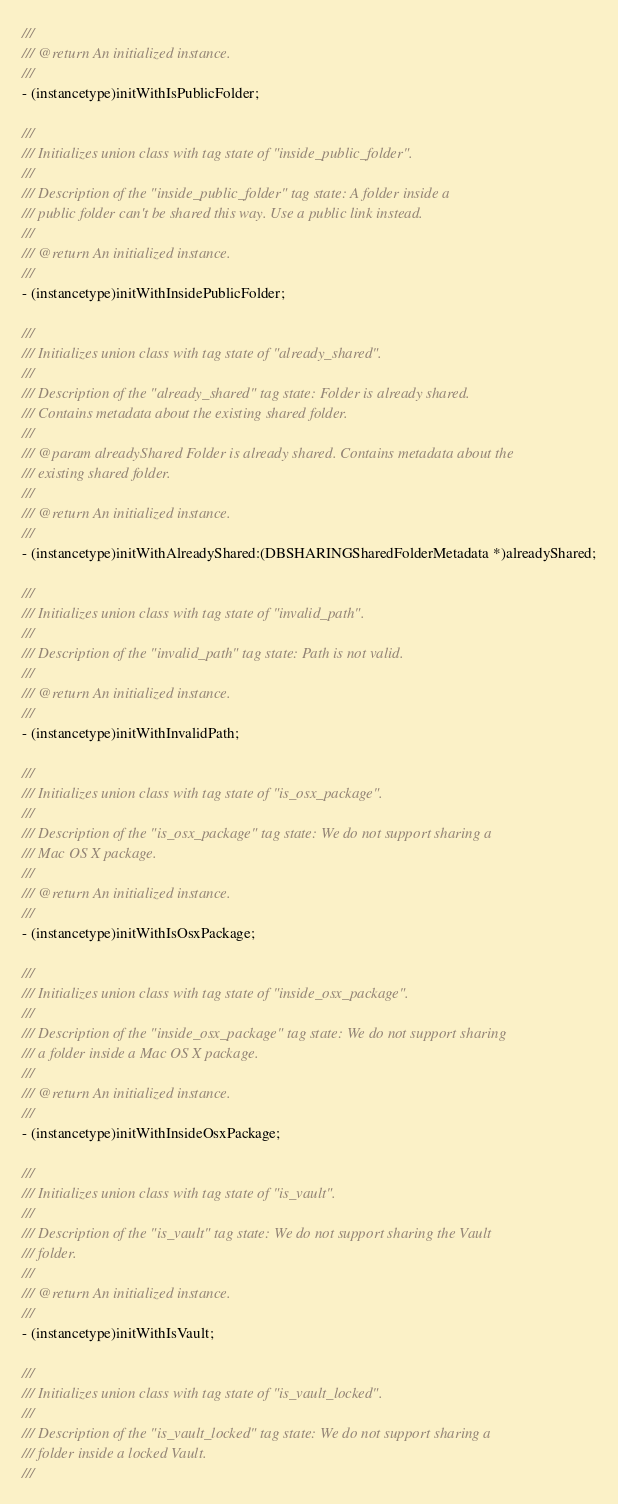<code> <loc_0><loc_0><loc_500><loc_500><_C_>///
/// @return An initialized instance.
///
- (instancetype)initWithIsPublicFolder;

///
/// Initializes union class with tag state of "inside_public_folder".
///
/// Description of the "inside_public_folder" tag state: A folder inside a
/// public folder can't be shared this way. Use a public link instead.
///
/// @return An initialized instance.
///
- (instancetype)initWithInsidePublicFolder;

///
/// Initializes union class with tag state of "already_shared".
///
/// Description of the "already_shared" tag state: Folder is already shared.
/// Contains metadata about the existing shared folder.
///
/// @param alreadyShared Folder is already shared. Contains metadata about the
/// existing shared folder.
///
/// @return An initialized instance.
///
- (instancetype)initWithAlreadyShared:(DBSHARINGSharedFolderMetadata *)alreadyShared;

///
/// Initializes union class with tag state of "invalid_path".
///
/// Description of the "invalid_path" tag state: Path is not valid.
///
/// @return An initialized instance.
///
- (instancetype)initWithInvalidPath;

///
/// Initializes union class with tag state of "is_osx_package".
///
/// Description of the "is_osx_package" tag state: We do not support sharing a
/// Mac OS X package.
///
/// @return An initialized instance.
///
- (instancetype)initWithIsOsxPackage;

///
/// Initializes union class with tag state of "inside_osx_package".
///
/// Description of the "inside_osx_package" tag state: We do not support sharing
/// a folder inside a Mac OS X package.
///
/// @return An initialized instance.
///
- (instancetype)initWithInsideOsxPackage;

///
/// Initializes union class with tag state of "is_vault".
///
/// Description of the "is_vault" tag state: We do not support sharing the Vault
/// folder.
///
/// @return An initialized instance.
///
- (instancetype)initWithIsVault;

///
/// Initializes union class with tag state of "is_vault_locked".
///
/// Description of the "is_vault_locked" tag state: We do not support sharing a
/// folder inside a locked Vault.
///</code> 